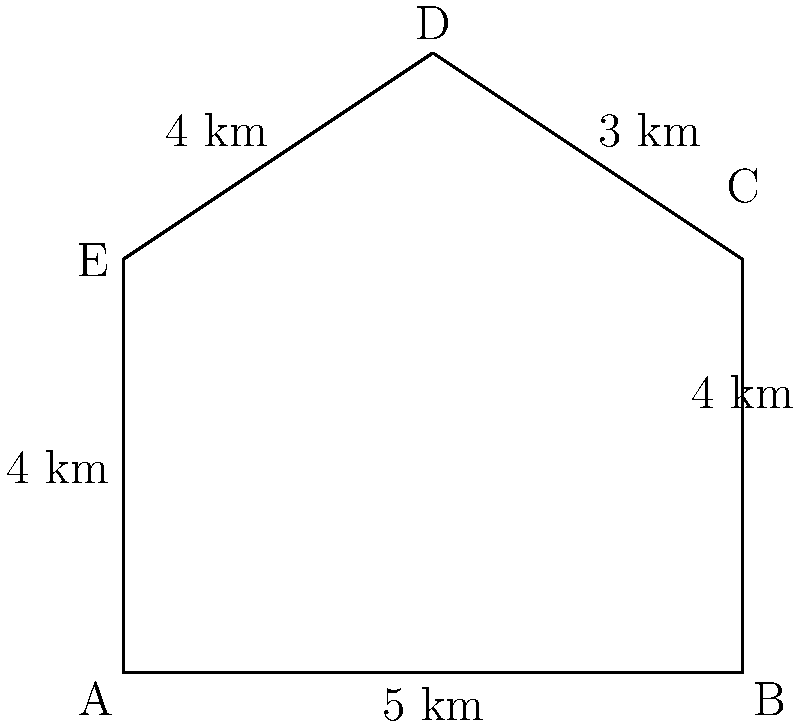As part of a geography lesson on Hungary, you're teaching students about the country's shape. You've simplified Hungary's outline into a polygon with five sides, as shown in the diagram. If each unit in the diagram represents 1 km, what is the perimeter of this simplified outline of Hungary in kilometers? Let's calculate the perimeter step by step:

1. The perimeter of a polygon is the sum of the lengths of all its sides.

2. From the diagram, we can see the lengths of each side:
   - Side AB = 5 km
   - Side BC = 4 km
   - Side CD = 3 km
   - Side DE = 4 km
   - Side EA = 4 km

3. To find the perimeter, we add all these lengths:

   $$\text{Perimeter} = AB + BC + CD + DE + EA$$
   $$\text{Perimeter} = 5 + 4 + 3 + 4 + 4$$
   $$\text{Perimeter} = 20 \text{ km}$$

Therefore, the perimeter of the simplified outline of Hungary is 20 km.
Answer: 20 km 